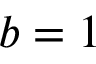<formula> <loc_0><loc_0><loc_500><loc_500>b = 1</formula> 